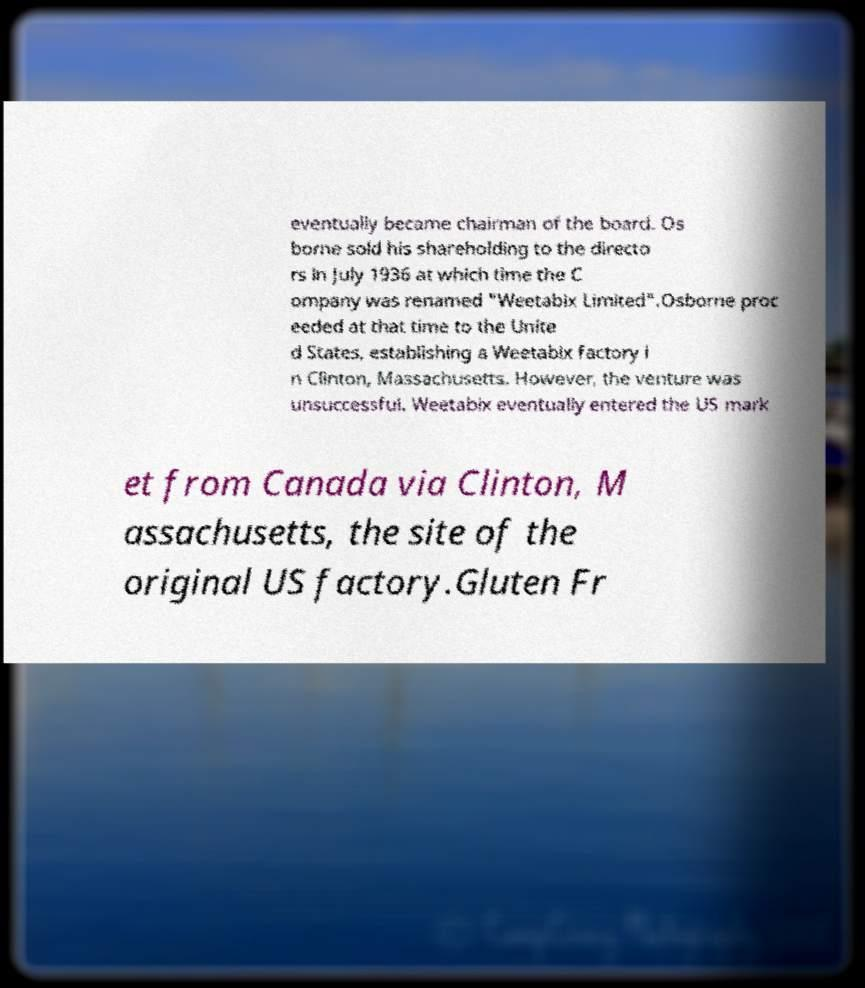For documentation purposes, I need the text within this image transcribed. Could you provide that? eventually became chairman of the board. Os borne sold his shareholding to the directo rs in July 1936 at which time the C ompany was renamed "Weetabix Limited".Osborne proc eeded at that time to the Unite d States, establishing a Weetabix factory i n Clinton, Massachusetts. However, the venture was unsuccessful. Weetabix eventually entered the US mark et from Canada via Clinton, M assachusetts, the site of the original US factory.Gluten Fr 